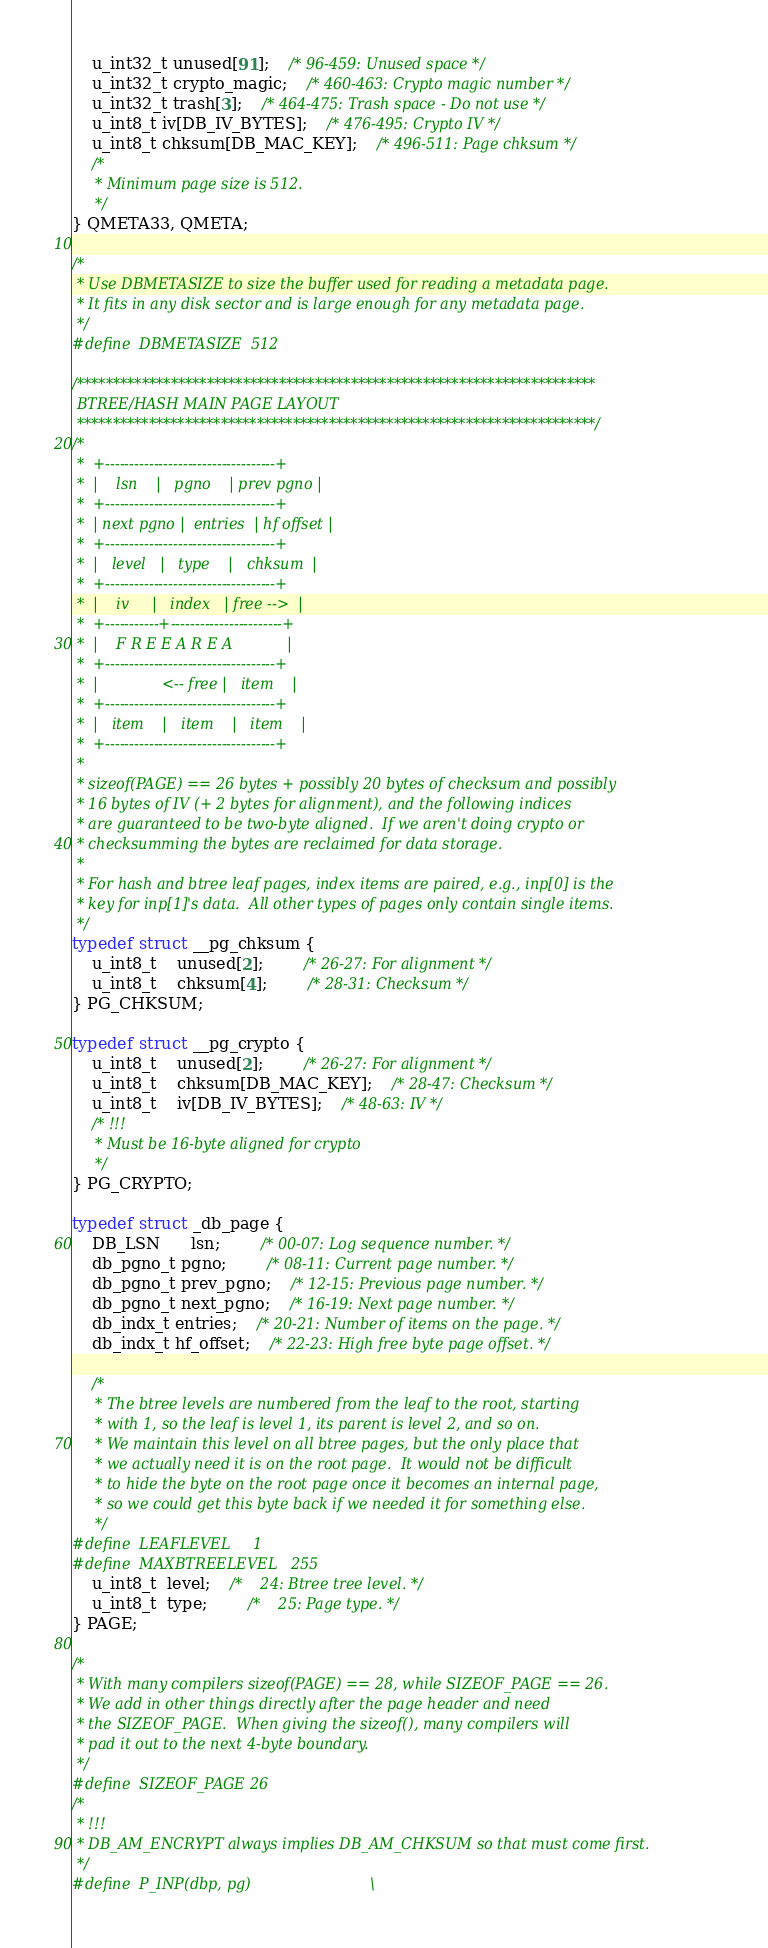Convert code to text. <code><loc_0><loc_0><loc_500><loc_500><_C_>
	u_int32_t unused[91];	/* 96-459: Unused space */
	u_int32_t crypto_magic;	/* 460-463: Crypto magic number */
	u_int32_t trash[3];	/* 464-475: Trash space - Do not use */
	u_int8_t iv[DB_IV_BYTES];	/* 476-495: Crypto IV */
	u_int8_t chksum[DB_MAC_KEY];	/* 496-511: Page chksum */
	/*
	 * Minimum page size is 512.
	 */
} QMETA33, QMETA;

/*
 * Use DBMETASIZE to size the buffer used for reading a metadata page.
 * It fits in any disk sector and is large enough for any metadata page.
 */
#define	DBMETASIZE	512

/************************************************************************
 BTREE/HASH MAIN PAGE LAYOUT
 ************************************************************************/
/*
 *	+-----------------------------------+
 *	|    lsn    |   pgno    | prev pgno |
 *	+-----------------------------------+
 *	| next pgno |  entries  | hf offset |
 *	+-----------------------------------+
 *	|   level   |   type    |   chksum  |
 *	+-----------------------------------+
 *	|    iv     |   index   | free -->  |
 *	+-----------+-----------------------+
 *	|	 F R E E A R E A            |
 *	+-----------------------------------+
 *	|              <-- free |   item    |
 *	+-----------------------------------+
 *	|   item    |   item    |   item    |
 *	+-----------------------------------+
 *
 * sizeof(PAGE) == 26 bytes + possibly 20 bytes of checksum and possibly
 * 16 bytes of IV (+ 2 bytes for alignment), and the following indices
 * are guaranteed to be two-byte aligned.  If we aren't doing crypto or
 * checksumming the bytes are reclaimed for data storage.
 *
 * For hash and btree leaf pages, index items are paired, e.g., inp[0] is the
 * key for inp[1]'s data.  All other types of pages only contain single items.
 */
typedef struct __pg_chksum {
	u_int8_t	unused[2];		/* 26-27: For alignment */
	u_int8_t	chksum[4];		/* 28-31: Checksum */
} PG_CHKSUM;

typedef struct __pg_crypto {
	u_int8_t	unused[2];		/* 26-27: For alignment */
	u_int8_t	chksum[DB_MAC_KEY];	/* 28-47: Checksum */
	u_int8_t	iv[DB_IV_BYTES];	/* 48-63: IV */
	/* !!!
	 * Must be 16-byte aligned for crypto
	 */
} PG_CRYPTO;

typedef struct _db_page {
	DB_LSN	  lsn;		/* 00-07: Log sequence number. */
	db_pgno_t pgno;		/* 08-11: Current page number. */
	db_pgno_t prev_pgno;	/* 12-15: Previous page number. */
	db_pgno_t next_pgno;	/* 16-19: Next page number. */
	db_indx_t entries;	/* 20-21: Number of items on the page. */
	db_indx_t hf_offset;	/* 22-23: High free byte page offset. */

	/*
	 * The btree levels are numbered from the leaf to the root, starting
	 * with 1, so the leaf is level 1, its parent is level 2, and so on.
	 * We maintain this level on all btree pages, but the only place that
	 * we actually need it is on the root page.  It would not be difficult
	 * to hide the byte on the root page once it becomes an internal page,
	 * so we could get this byte back if we needed it for something else.
	 */
#define	LEAFLEVEL	  1
#define	MAXBTREELEVEL	255
	u_int8_t  level;	/*    24: Btree tree level. */
	u_int8_t  type;		/*    25: Page type. */
} PAGE;

/*
 * With many compilers sizeof(PAGE) == 28, while SIZEOF_PAGE == 26.
 * We add in other things directly after the page header and need
 * the SIZEOF_PAGE.  When giving the sizeof(), many compilers will
 * pad it out to the next 4-byte boundary.
 */
#define	SIZEOF_PAGE	26
/*
 * !!!
 * DB_AM_ENCRYPT always implies DB_AM_CHKSUM so that must come first.
 */
#define	P_INP(dbp, pg)							\</code> 